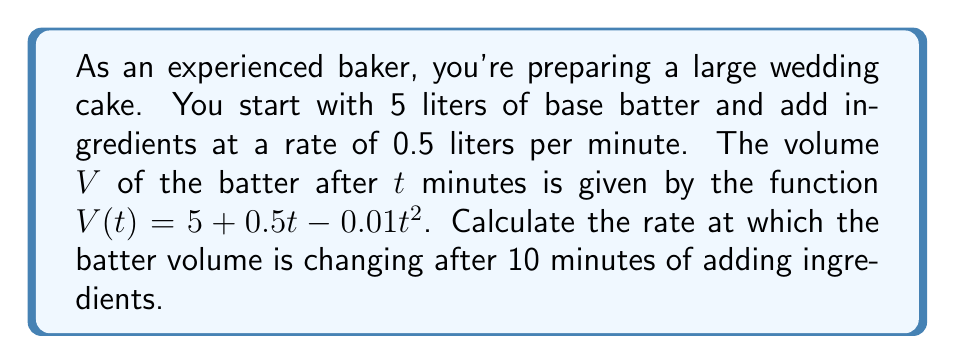Give your solution to this math problem. To find the rate of change in the batter volume after 10 minutes, we need to calculate the derivative of the volume function $V(t)$ and evaluate it at $t = 10$.

Step 1: Identify the given function
$$V(t) = 5 + 0.5t - 0.01t^2$$

Step 2: Calculate the derivative of $V(t)$
Using the power rule and constant rule of differentiation:
$$\frac{dV}{dt} = 0 + 0.5 - 0.02t$$

Step 3: Simplify the derivative
$$\frac{dV}{dt} = 0.5 - 0.02t$$

Step 4: Evaluate the derivative at $t = 10$
$$\frac{dV}{dt}\bigg|_{t=10} = 0.5 - 0.02(10)$$
$$\frac{dV}{dt}\bigg|_{t=10} = 0.5 - 0.2$$
$$\frac{dV}{dt}\bigg|_{t=10} = 0.3$$

Therefore, after 10 minutes of adding ingredients, the batter volume is changing at a rate of 0.3 liters per minute.
Answer: $0.3$ liters per minute 